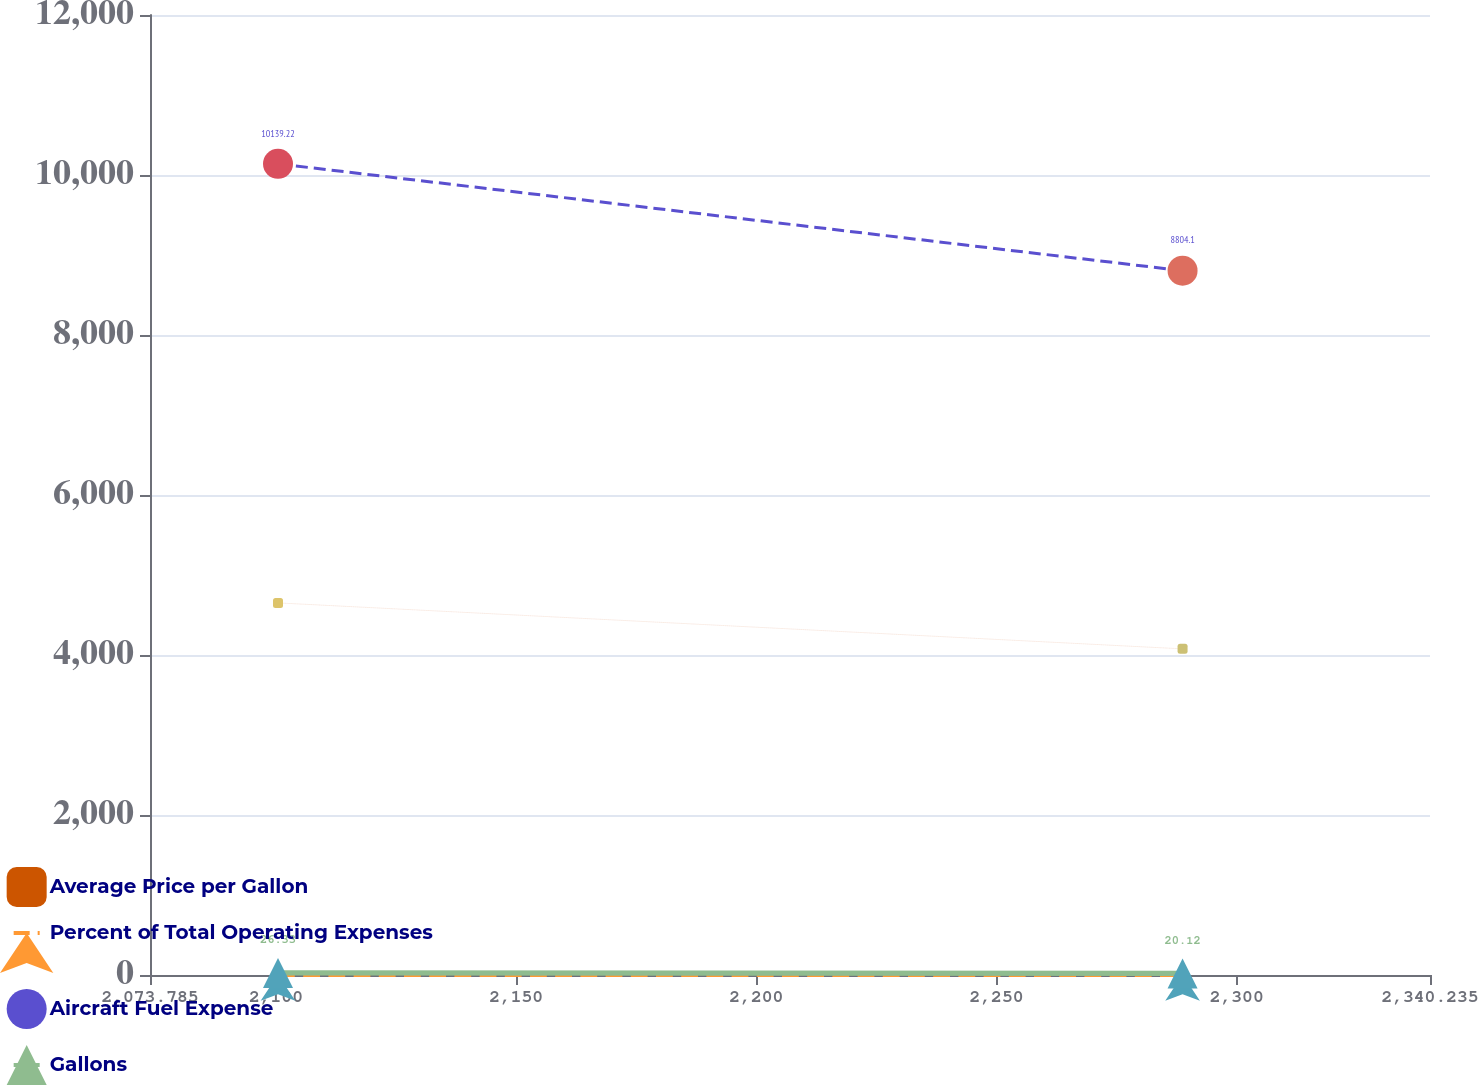Convert chart to OTSL. <chart><loc_0><loc_0><loc_500><loc_500><line_chart><ecel><fcel>Average Price per Gallon<fcel>Percent of Total Operating Expenses<fcel>Aircraft Fuel Expense<fcel>Gallons<nl><fcel>2100.43<fcel>4651.23<fcel>2.1<fcel>10139.2<fcel>26.33<nl><fcel>2288.73<fcel>4076.72<fcel>2.02<fcel>8804.1<fcel>20.12<nl><fcel>2366.88<fcel>3908.03<fcel>1.27<fcel>6246.48<fcel>16.47<nl></chart> 